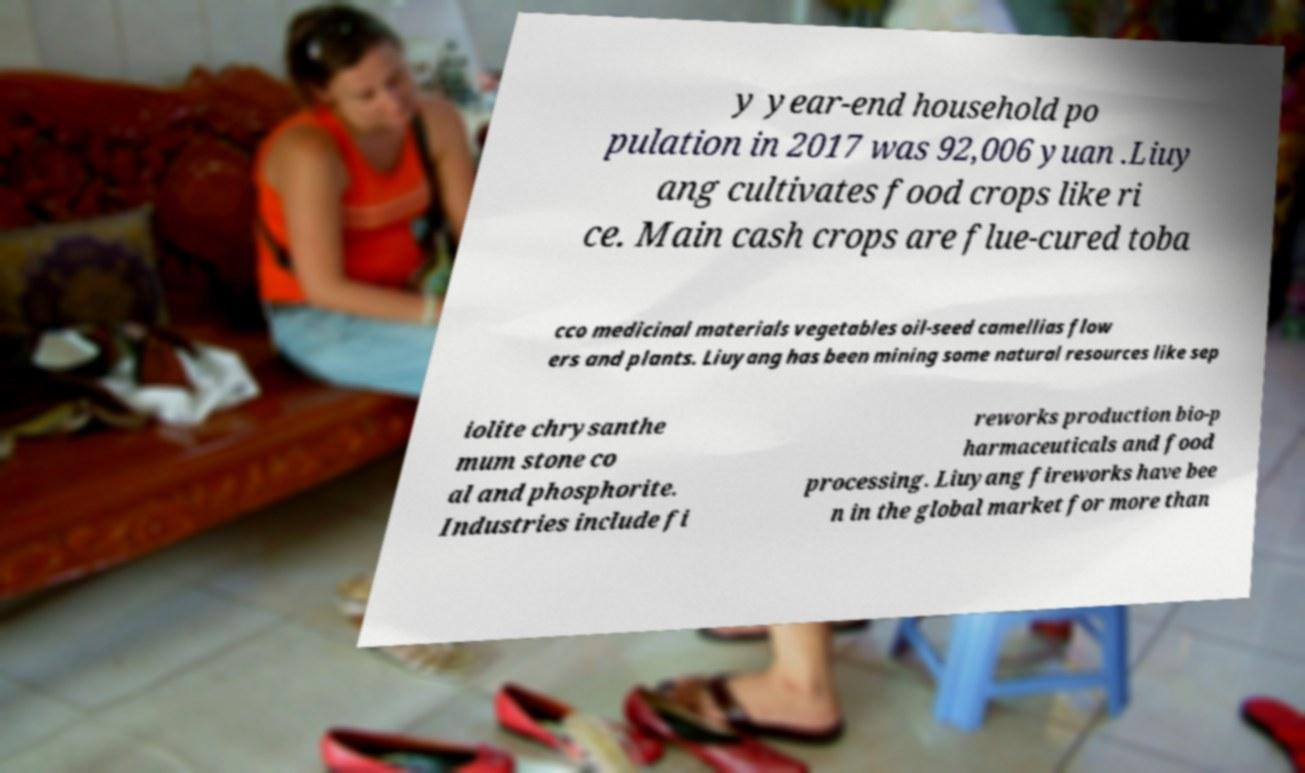Please identify and transcribe the text found in this image. y year-end household po pulation in 2017 was 92,006 yuan .Liuy ang cultivates food crops like ri ce. Main cash crops are flue-cured toba cco medicinal materials vegetables oil-seed camellias flow ers and plants. Liuyang has been mining some natural resources like sep iolite chrysanthe mum stone co al and phosphorite. Industries include fi reworks production bio-p harmaceuticals and food processing. Liuyang fireworks have bee n in the global market for more than 